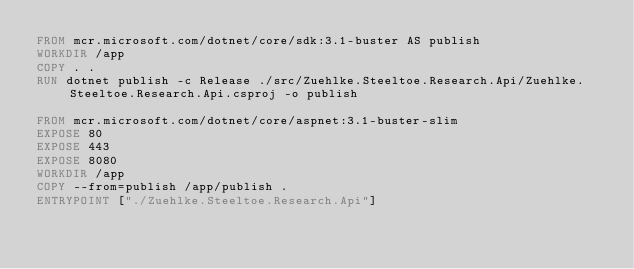Convert code to text. <code><loc_0><loc_0><loc_500><loc_500><_Dockerfile_>FROM mcr.microsoft.com/dotnet/core/sdk:3.1-buster AS publish
WORKDIR /app
COPY . .
RUN dotnet publish -c Release ./src/Zuehlke.Steeltoe.Research.Api/Zuehlke.Steeltoe.Research.Api.csproj -o publish

FROM mcr.microsoft.com/dotnet/core/aspnet:3.1-buster-slim
EXPOSE 80
EXPOSE 443
EXPOSE 8080
WORKDIR /app
COPY --from=publish /app/publish .
ENTRYPOINT ["./Zuehlke.Steeltoe.Research.Api"]</code> 